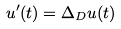Convert formula to latex. <formula><loc_0><loc_0><loc_500><loc_500>u ^ { \prime } ( t ) = \Delta _ { D } u ( t )</formula> 